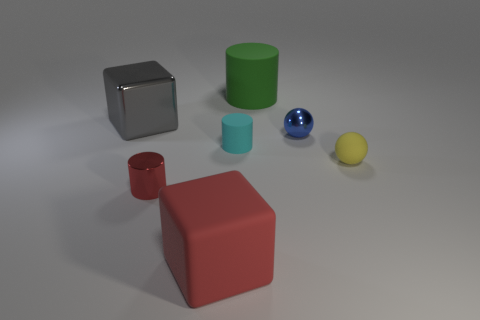There is a tiny object left of the cyan thing; does it have the same shape as the cyan object?
Provide a short and direct response. Yes. Are there any blue metal objects of the same size as the yellow object?
Give a very brief answer. Yes. There is a small red shiny object; is it the same shape as the metallic object to the right of the cyan cylinder?
Your response must be concise. No. There is a small object that is the same color as the rubber block; what shape is it?
Your response must be concise. Cylinder. Are there fewer large matte cubes that are to the left of the small red metal object than small blue rubber things?
Give a very brief answer. No. Do the small cyan thing and the blue shiny object have the same shape?
Offer a terse response. No. What is the size of the cylinder that is made of the same material as the large gray cube?
Provide a short and direct response. Small. Is the number of small yellow things less than the number of small green metal objects?
Ensure brevity in your answer.  No. What number of big objects are either red rubber objects or cubes?
Ensure brevity in your answer.  2. How many small things are both behind the tiny yellow matte ball and on the left side of the small cyan rubber thing?
Give a very brief answer. 0. 